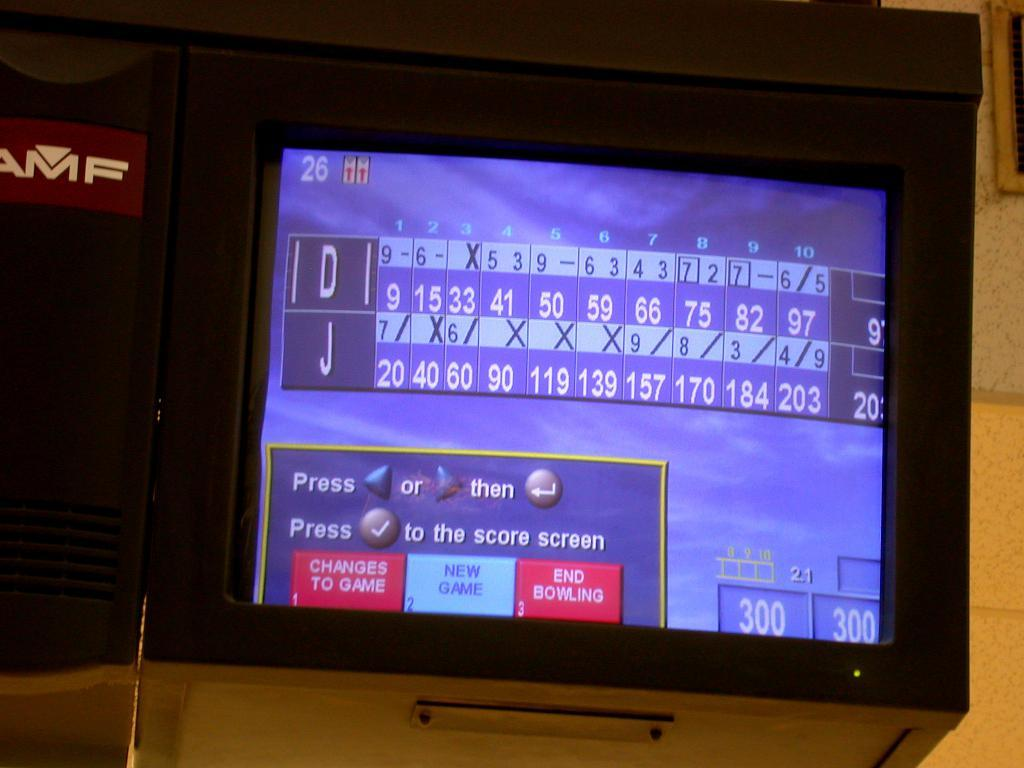What is the main object in the image? There is a screen in the image. What can be seen on the screen? There are numbers and text visible on the screen. What is the color of the text and numbers on the screen? The text and numbers on the screen are in blue color. How many bits of information are being distributed on the screen? There is no reference to bits or distribution in the image; it only shows a screen with numbers and text in blue color. 